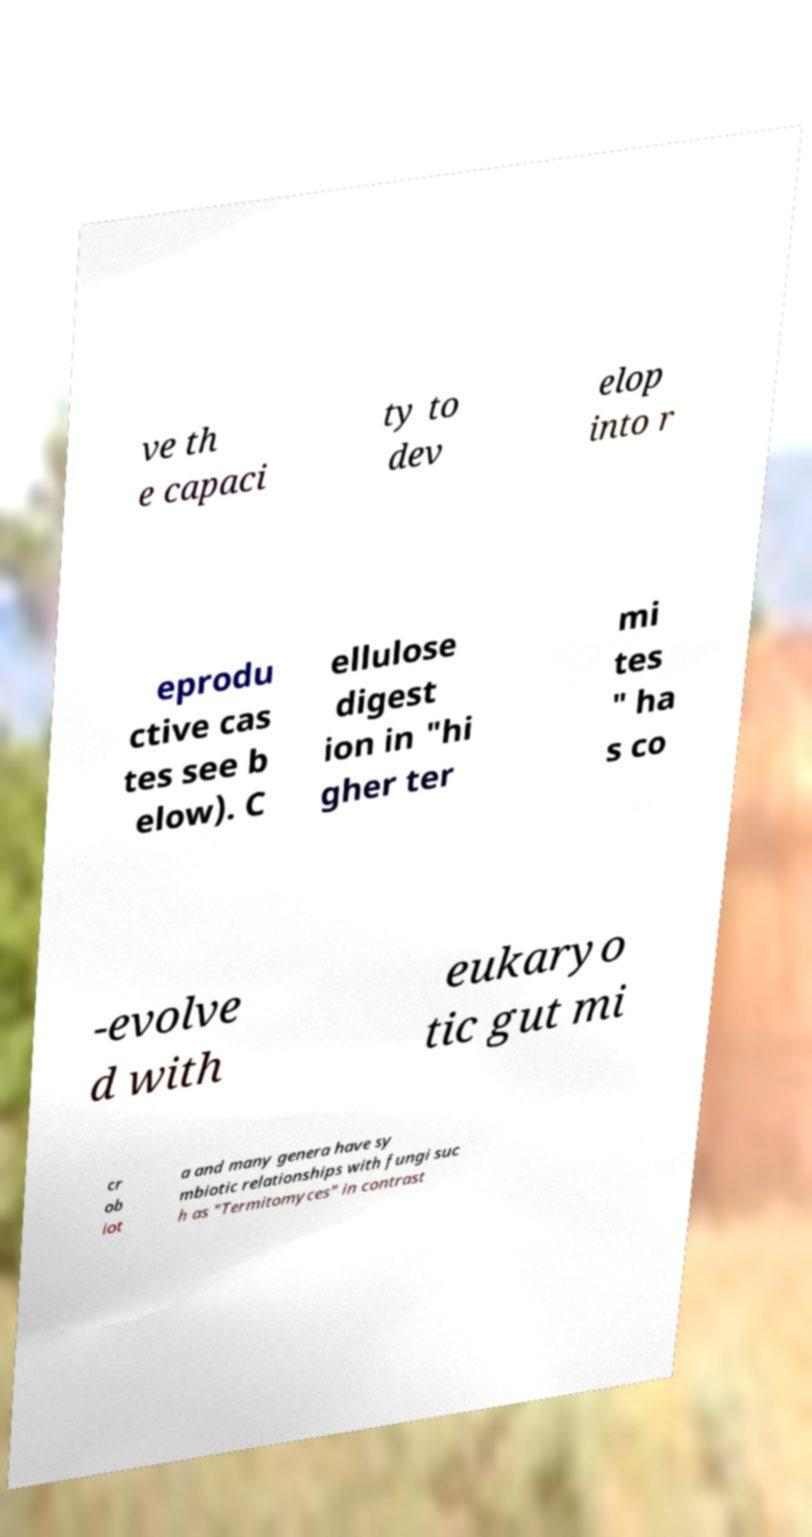Could you extract and type out the text from this image? ve th e capaci ty to dev elop into r eprodu ctive cas tes see b elow). C ellulose digest ion in "hi gher ter mi tes " ha s co -evolve d with eukaryo tic gut mi cr ob iot a and many genera have sy mbiotic relationships with fungi suc h as "Termitomyces" in contrast 